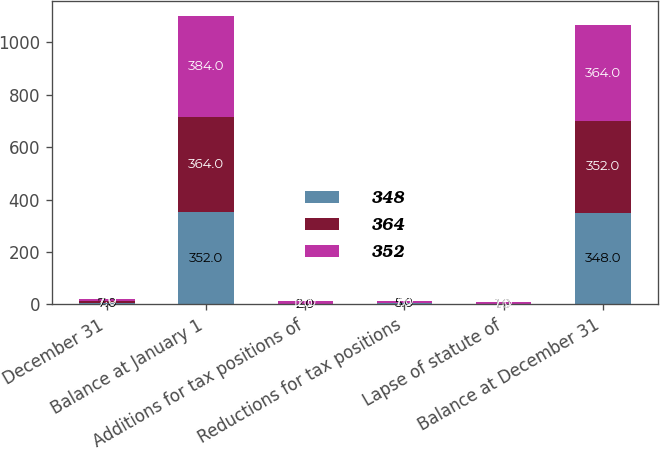<chart> <loc_0><loc_0><loc_500><loc_500><stacked_bar_chart><ecel><fcel>December 31<fcel>Balance at January 1<fcel>Additions for tax positions of<fcel>Reductions for tax positions<fcel>Lapse of statute of<fcel>Balance at December 31<nl><fcel>348<fcel>7<fcel>352<fcel>2<fcel>5<fcel>1<fcel>348<nl><fcel>364<fcel>7<fcel>364<fcel>1<fcel>1<fcel>1<fcel>352<nl><fcel>352<fcel>7<fcel>384<fcel>12<fcel>7<fcel>7<fcel>364<nl></chart> 